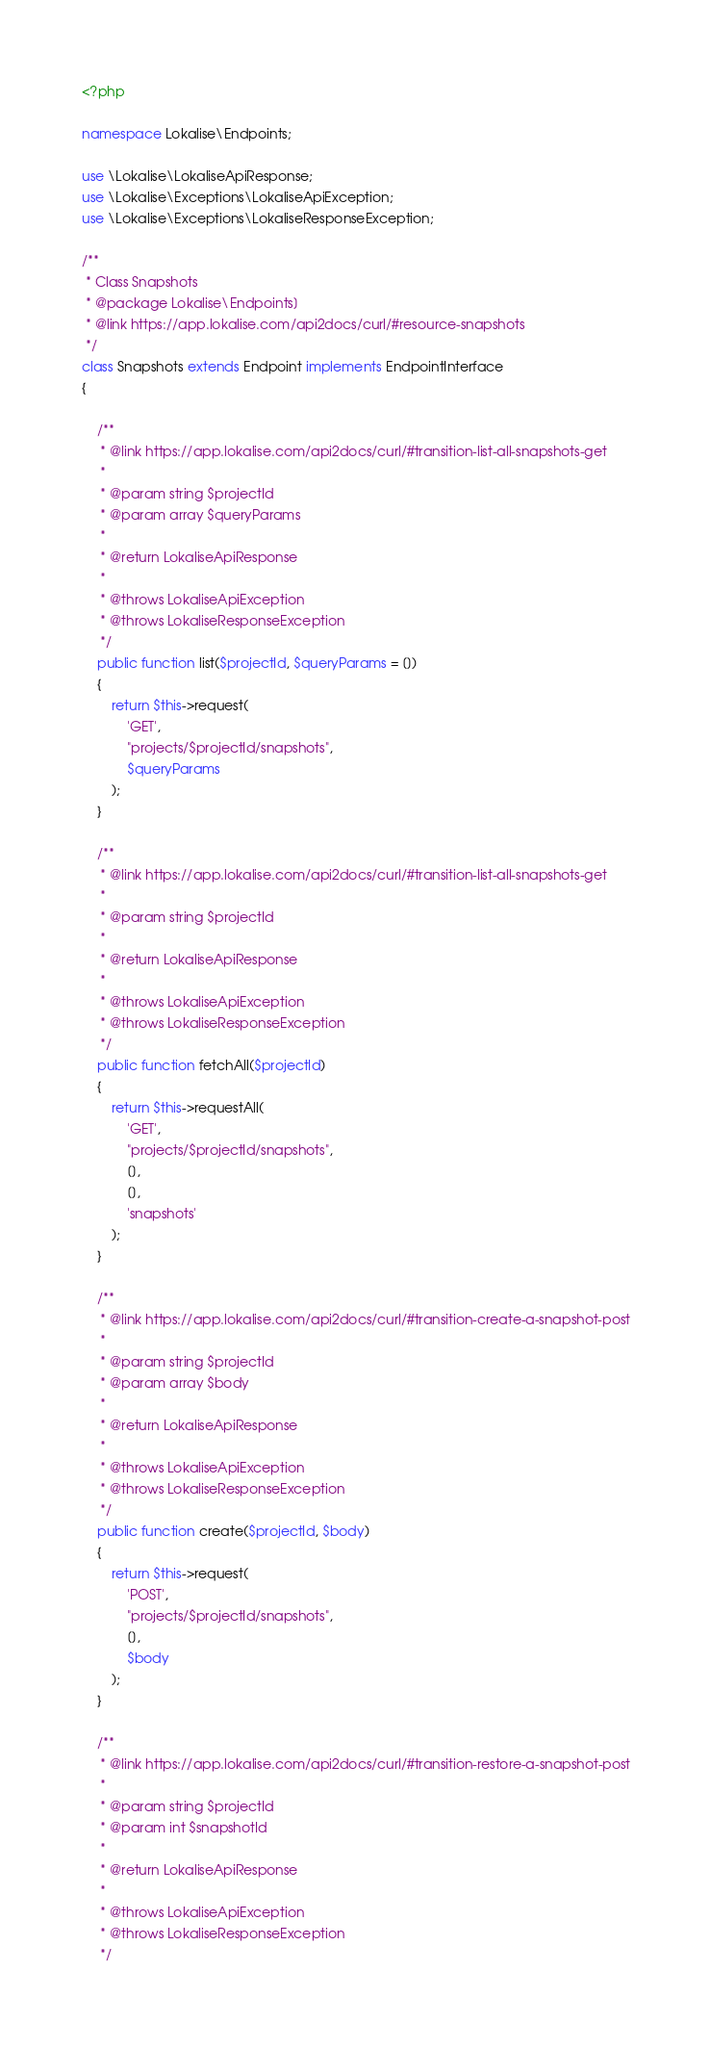<code> <loc_0><loc_0><loc_500><loc_500><_PHP_><?php

namespace Lokalise\Endpoints;

use \Lokalise\LokaliseApiResponse;
use \Lokalise\Exceptions\LokaliseApiException;
use \Lokalise\Exceptions\LokaliseResponseException;

/**
 * Class Snapshots
 * @package Lokalise\Endpoints]
 * @link https://app.lokalise.com/api2docs/curl/#resource-snapshots
 */
class Snapshots extends Endpoint implements EndpointInterface
{

    /**
     * @link https://app.lokalise.com/api2docs/curl/#transition-list-all-snapshots-get
     *
     * @param string $projectId
     * @param array $queryParams
     *
     * @return LokaliseApiResponse
     *
     * @throws LokaliseApiException
     * @throws LokaliseResponseException
     */
    public function list($projectId, $queryParams = [])
    {
        return $this->request(
            'GET',
            "projects/$projectId/snapshots",
            $queryParams
        );
    }

    /**
     * @link https://app.lokalise.com/api2docs/curl/#transition-list-all-snapshots-get
     *
     * @param string $projectId
     *
     * @return LokaliseApiResponse
     *
     * @throws LokaliseApiException
     * @throws LokaliseResponseException
     */
    public function fetchAll($projectId)
    {
        return $this->requestAll(
            'GET',
            "projects/$projectId/snapshots",
            [],
            [],
            'snapshots'
        );
    }

    /**
     * @link https://app.lokalise.com/api2docs/curl/#transition-create-a-snapshot-post
     *
     * @param string $projectId
     * @param array $body
     *
     * @return LokaliseApiResponse
     *
     * @throws LokaliseApiException
     * @throws LokaliseResponseException
     */
    public function create($projectId, $body)
    {
        return $this->request(
            'POST',
            "projects/$projectId/snapshots",
            [],
            $body
        );
    }

    /**
     * @link https://app.lokalise.com/api2docs/curl/#transition-restore-a-snapshot-post
     *
     * @param string $projectId
     * @param int $snapshotId
     *
     * @return LokaliseApiResponse
     *
     * @throws LokaliseApiException
     * @throws LokaliseResponseException
     */</code> 